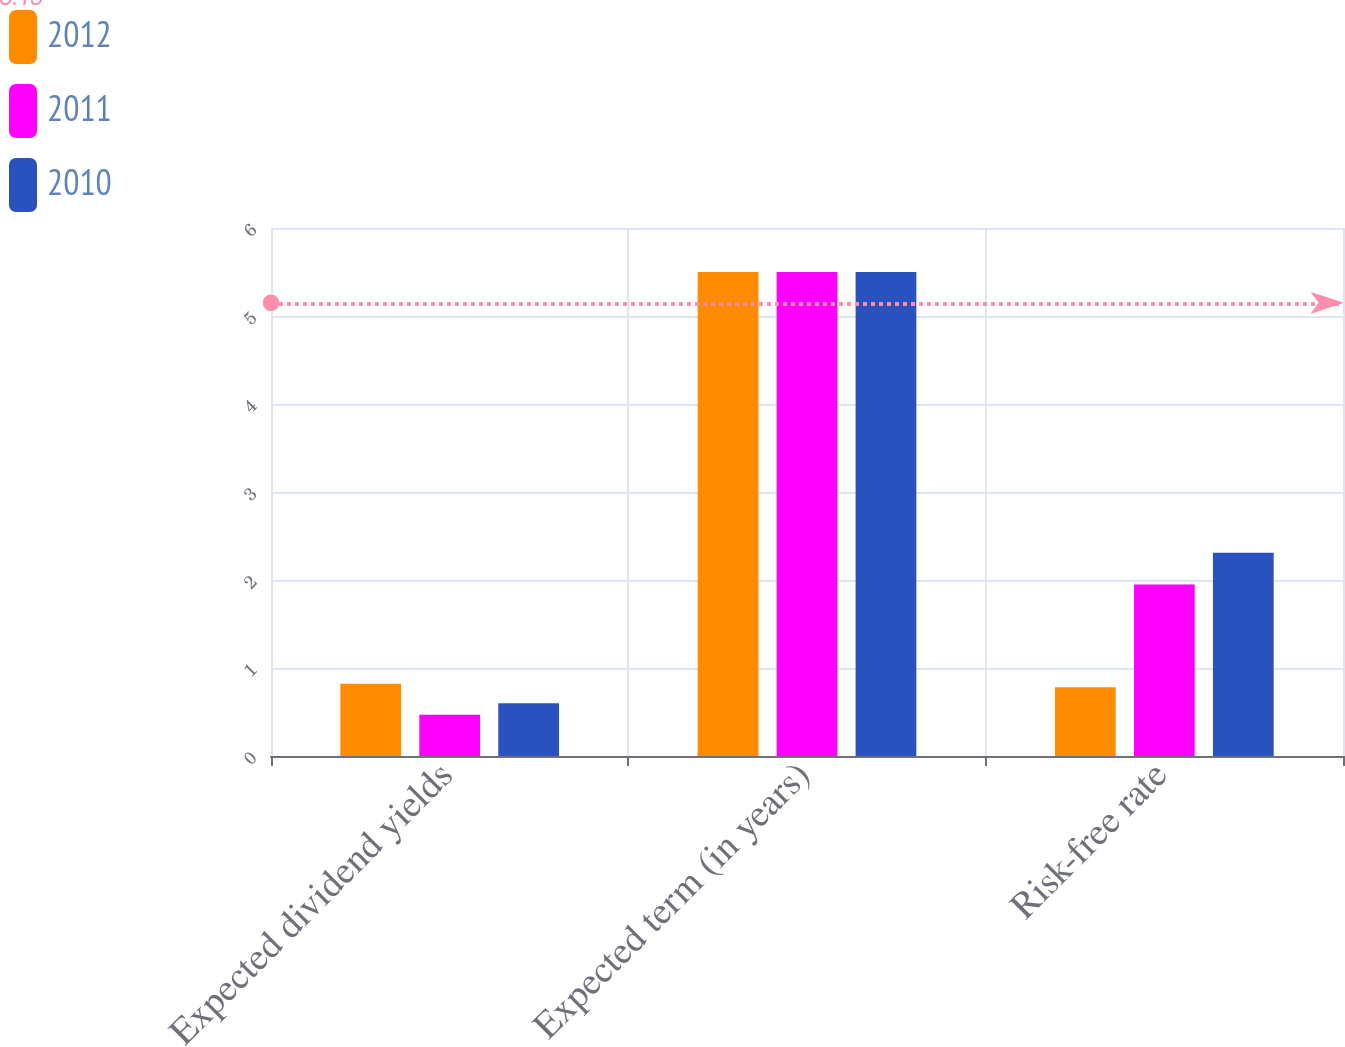<chart> <loc_0><loc_0><loc_500><loc_500><stacked_bar_chart><ecel><fcel>Expected dividend yields<fcel>Expected term (in years)<fcel>Risk-free rate<nl><fcel>2012<fcel>0.82<fcel>5.5<fcel>0.78<nl><fcel>2011<fcel>0.47<fcel>5.5<fcel>1.95<nl><fcel>2010<fcel>0.6<fcel>5.5<fcel>2.31<nl></chart> 